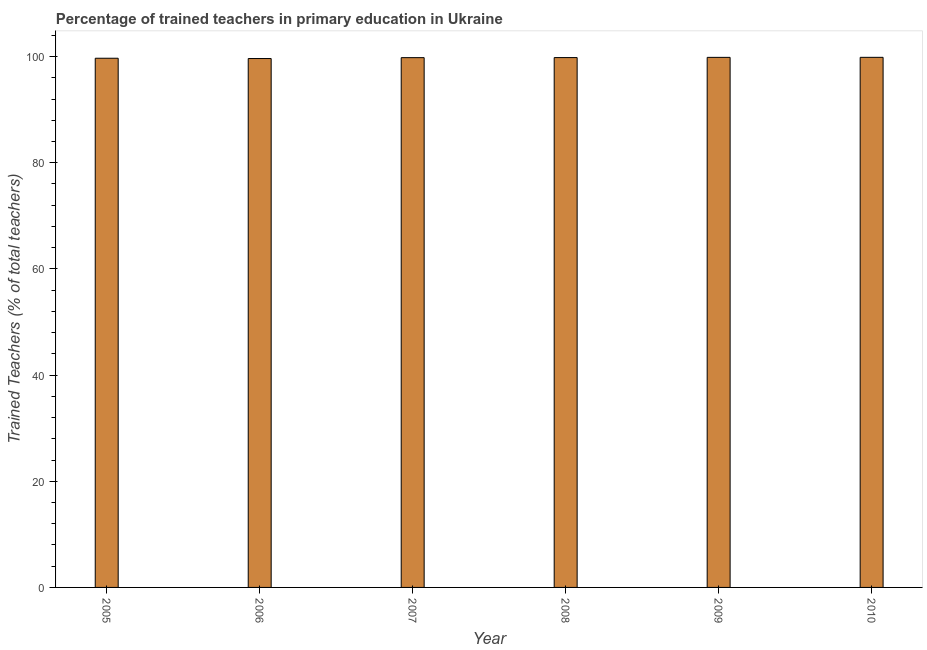Does the graph contain grids?
Your response must be concise. No. What is the title of the graph?
Keep it short and to the point. Percentage of trained teachers in primary education in Ukraine. What is the label or title of the Y-axis?
Offer a terse response. Trained Teachers (% of total teachers). What is the percentage of trained teachers in 2006?
Ensure brevity in your answer.  99.63. Across all years, what is the maximum percentage of trained teachers?
Offer a very short reply. 99.86. Across all years, what is the minimum percentage of trained teachers?
Offer a terse response. 99.63. In which year was the percentage of trained teachers maximum?
Provide a succinct answer. 2010. What is the sum of the percentage of trained teachers?
Your response must be concise. 598.66. What is the difference between the percentage of trained teachers in 2008 and 2009?
Your response must be concise. -0.04. What is the average percentage of trained teachers per year?
Offer a terse response. 99.78. What is the median percentage of trained teachers?
Your answer should be very brief. 99.81. What is the ratio of the percentage of trained teachers in 2005 to that in 2006?
Make the answer very short. 1. Is the percentage of trained teachers in 2006 less than that in 2010?
Offer a very short reply. Yes. What is the difference between the highest and the second highest percentage of trained teachers?
Provide a succinct answer. 0.01. What is the difference between the highest and the lowest percentage of trained teachers?
Give a very brief answer. 0.23. In how many years, is the percentage of trained teachers greater than the average percentage of trained teachers taken over all years?
Ensure brevity in your answer.  4. Are the values on the major ticks of Y-axis written in scientific E-notation?
Provide a short and direct response. No. What is the Trained Teachers (% of total teachers) in 2005?
Offer a terse response. 99.69. What is the Trained Teachers (% of total teachers) in 2006?
Make the answer very short. 99.63. What is the Trained Teachers (% of total teachers) in 2007?
Your answer should be compact. 99.8. What is the Trained Teachers (% of total teachers) in 2008?
Keep it short and to the point. 99.82. What is the Trained Teachers (% of total teachers) in 2009?
Your answer should be very brief. 99.86. What is the Trained Teachers (% of total teachers) of 2010?
Provide a short and direct response. 99.86. What is the difference between the Trained Teachers (% of total teachers) in 2005 and 2006?
Your response must be concise. 0.06. What is the difference between the Trained Teachers (% of total teachers) in 2005 and 2007?
Provide a succinct answer. -0.11. What is the difference between the Trained Teachers (% of total teachers) in 2005 and 2008?
Provide a short and direct response. -0.12. What is the difference between the Trained Teachers (% of total teachers) in 2005 and 2009?
Give a very brief answer. -0.17. What is the difference between the Trained Teachers (% of total teachers) in 2005 and 2010?
Your answer should be compact. -0.17. What is the difference between the Trained Teachers (% of total teachers) in 2006 and 2007?
Your answer should be compact. -0.17. What is the difference between the Trained Teachers (% of total teachers) in 2006 and 2008?
Offer a very short reply. -0.18. What is the difference between the Trained Teachers (% of total teachers) in 2006 and 2009?
Give a very brief answer. -0.22. What is the difference between the Trained Teachers (% of total teachers) in 2006 and 2010?
Provide a short and direct response. -0.23. What is the difference between the Trained Teachers (% of total teachers) in 2007 and 2008?
Keep it short and to the point. -0.01. What is the difference between the Trained Teachers (% of total teachers) in 2007 and 2009?
Make the answer very short. -0.05. What is the difference between the Trained Teachers (% of total teachers) in 2007 and 2010?
Offer a terse response. -0.06. What is the difference between the Trained Teachers (% of total teachers) in 2008 and 2009?
Your answer should be compact. -0.04. What is the difference between the Trained Teachers (% of total teachers) in 2008 and 2010?
Your answer should be very brief. -0.05. What is the difference between the Trained Teachers (% of total teachers) in 2009 and 2010?
Your answer should be compact. -0.01. What is the ratio of the Trained Teachers (% of total teachers) in 2005 to that in 2006?
Your answer should be compact. 1. What is the ratio of the Trained Teachers (% of total teachers) in 2005 to that in 2010?
Your answer should be very brief. 1. What is the ratio of the Trained Teachers (% of total teachers) in 2006 to that in 2008?
Offer a very short reply. 1. What is the ratio of the Trained Teachers (% of total teachers) in 2007 to that in 2009?
Ensure brevity in your answer.  1. What is the ratio of the Trained Teachers (% of total teachers) in 2007 to that in 2010?
Provide a succinct answer. 1. What is the ratio of the Trained Teachers (% of total teachers) in 2008 to that in 2009?
Provide a succinct answer. 1. 